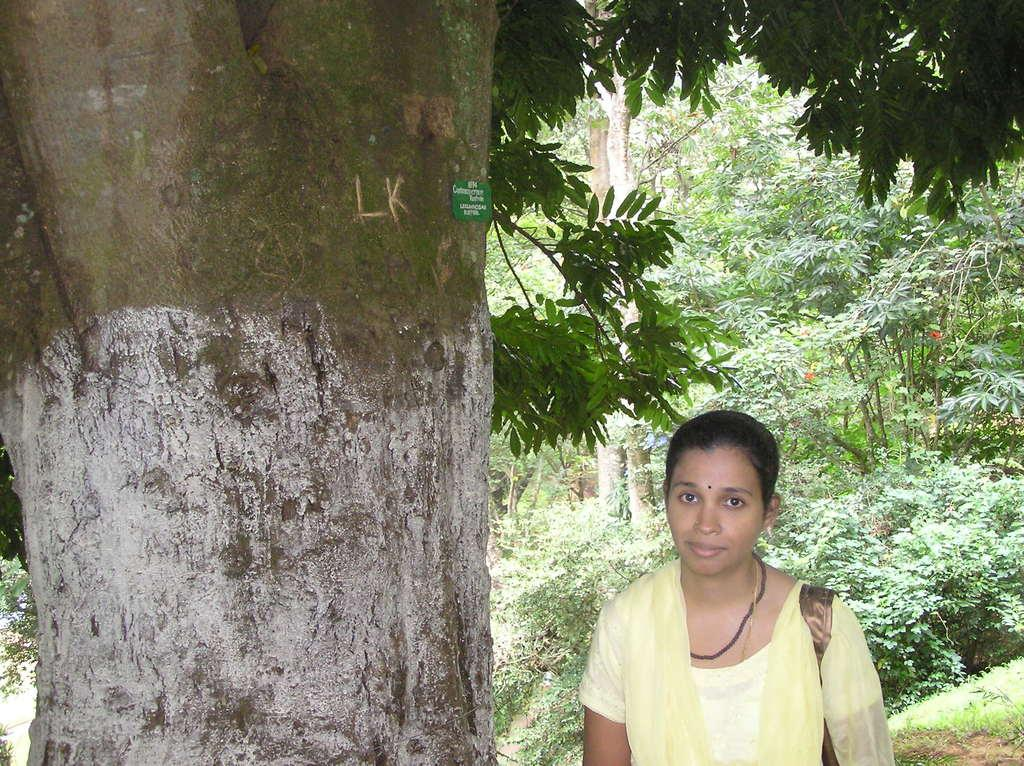What is the primary feature of the image? There are many trees in the image. Can you describe the person in the image? A lady is standing in the image. What is the lady holding or carrying? The lady is carrying an object. What type of thrill can be seen in the lady's eyes in the image? There is no indication of any specific emotion or thrill in the lady's eyes in the image. Can you identify any beasts in the image? There are no beasts present in the image; it features trees and a lady. 